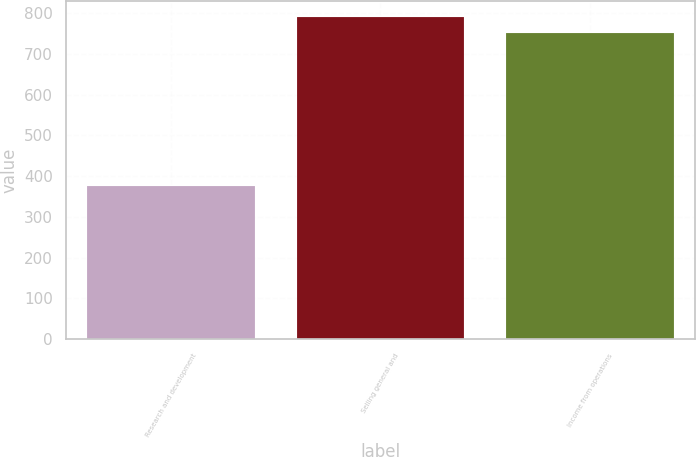Convert chart. <chart><loc_0><loc_0><loc_500><loc_500><bar_chart><fcel>Research and development<fcel>Selling general and<fcel>Income from operations<nl><fcel>375<fcel>789.6<fcel>751<nl></chart> 